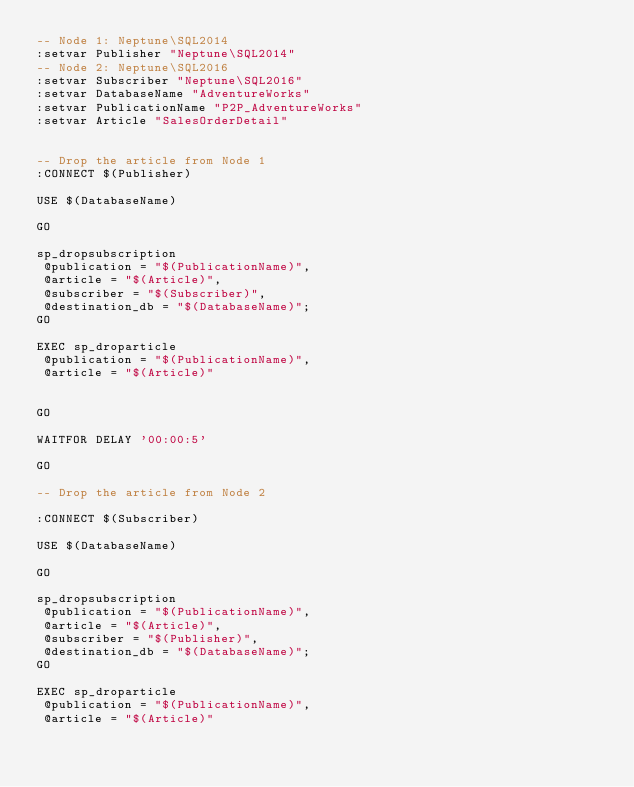Convert code to text. <code><loc_0><loc_0><loc_500><loc_500><_SQL_>-- Node 1: Neptune\SQL2014
:setvar Publisher "Neptune\SQL2014"
-- Node 2: Neptune\SQL2016
:setvar Subscriber "Neptune\SQL2016"
:setvar DatabaseName "AdventureWorks"
:setvar PublicationName "P2P_AdventureWorks"
:setvar Article "SalesOrderDetail"


-- Drop the article from Node 1
:CONNECT $(Publisher)

USE $(DatabaseName)

GO

sp_dropsubscription
 @publication = "$(PublicationName)",
 @article = "$(Article)",
 @subscriber = "$(Subscriber)",
 @destination_db = "$(DatabaseName)";
GO

EXEC sp_droparticle
 @publication = "$(PublicationName)",
 @article = "$(Article)"


GO

WAITFOR DELAY '00:00:5'

GO

-- Drop the article from Node 2

:CONNECT $(Subscriber)

USE $(DatabaseName)

GO

sp_dropsubscription
 @publication = "$(PublicationName)",
 @article = "$(Article)",
 @subscriber = "$(Publisher)",
 @destination_db = "$(DatabaseName)";
GO

EXEC sp_droparticle
 @publication = "$(PublicationName)",
 @article = "$(Article)" 
</code> 